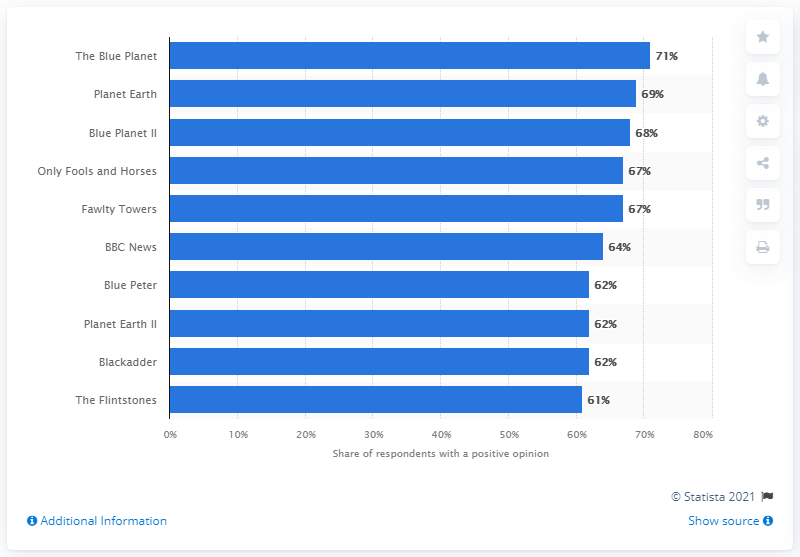Mention a couple of crucial points in this snapshot. In the first quarter of 2021, the highest-ranked television show in the UK was "The Blue Planet. 